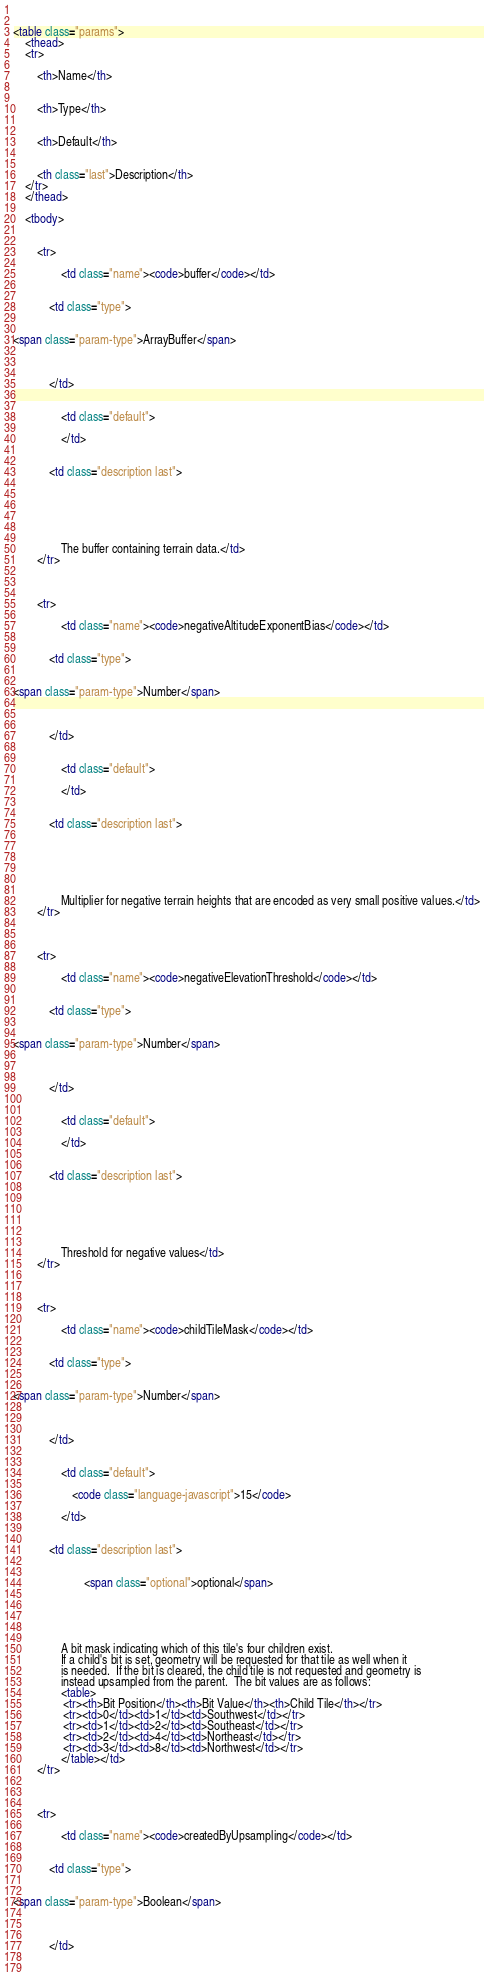<code> <loc_0><loc_0><loc_500><loc_500><_HTML_>                

<table class="params">
    <thead>
    <tr>
        
        <th>Name</th>
        

        <th>Type</th>

        
        <th>Default</th>
        

        <th class="last">Description</th>
    </tr>
    </thead>

    <tbody>
    

        <tr>
            
                <td class="name"><code>buffer</code></td>
            

            <td class="type">
            
                
<span class="param-type">ArrayBuffer</span>


            
            </td>

            
                <td class="default">
                
                </td>
            

            <td class="description last">
            
                
                

                
            
                The buffer containing terrain data.</td>
        </tr>

    

        <tr>
            
                <td class="name"><code>negativeAltitudeExponentBias</code></td>
            

            <td class="type">
            
                
<span class="param-type">Number</span>


            
            </td>

            
                <td class="default">
                
                </td>
            

            <td class="description last">
            
                
                

                
            
                Multiplier for negative terrain heights that are encoded as very small positive values.</td>
        </tr>

    

        <tr>
            
                <td class="name"><code>negativeElevationThreshold</code></td>
            

            <td class="type">
            
                
<span class="param-type">Number</span>


            
            </td>

            
                <td class="default">
                
                </td>
            

            <td class="description last">
            
                
                

                
            
                Threshold for negative values</td>
        </tr>

    

        <tr>
            
                <td class="name"><code>childTileMask</code></td>
            

            <td class="type">
            
                
<span class="param-type">Number</span>


            
            </td>

            
                <td class="default">
                
                    <code class="language-javascript">15</code>
                
                </td>
            

            <td class="description last">
            
                
                        <span class="optional">optional</span>
                
                

                
            
                A bit mask indicating which of this tile's four children exist.                If a child's bit is set, geometry will be requested for that tile as well when it                is needed.  If the bit is cleared, the child tile is not requested and geometry is                instead upsampled from the parent.  The bit values are as follows:                <table>                 <tr><th>Bit Position</th><th>Bit Value</th><th>Child Tile</th></tr>                 <tr><td>0</td><td>1</td><td>Southwest</td></tr>                 <tr><td>1</td><td>2</td><td>Southeast</td></tr>                 <tr><td>2</td><td>4</td><td>Northeast</td></tr>                 <tr><td>3</td><td>8</td><td>Northwest</td></tr>                </table></td>
        </tr>

    

        <tr>
            
                <td class="name"><code>createdByUpsampling</code></td>
            

            <td class="type">
            
                
<span class="param-type">Boolean</span>


            
            </td>

            </code> 